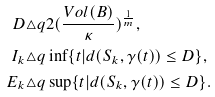Convert formula to latex. <formula><loc_0><loc_0><loc_500><loc_500>D & \triangle q 2 ( \frac { V o l ( B ) } { \kappa } ) ^ { \frac { 1 } { m } } , \\ I _ { k } & \triangle q \inf \{ t | d ( S _ { k } , \gamma ( t ) ) \leq D \} , \\ E _ { k } & \triangle q \sup \{ t | d ( S _ { k } , \gamma ( t ) ) \leq D \} .</formula> 